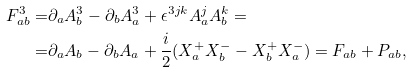<formula> <loc_0><loc_0><loc_500><loc_500>F ^ { 3 } _ { a b } = & \partial _ { a } A ^ { 3 } _ { b } - \partial _ { b } A ^ { 3 } _ { a } + \epsilon ^ { 3 j k } A ^ { j } _ { a } A ^ { k } _ { b } = \\ = & \partial _ { a } A _ { b } - \partial _ { b } A _ { a } + \frac { i } { 2 } ( X ^ { + } _ { a } X ^ { - } _ { b } - X ^ { + } _ { b } X ^ { - } _ { a } ) = F _ { a b } + P _ { a b } ,</formula> 